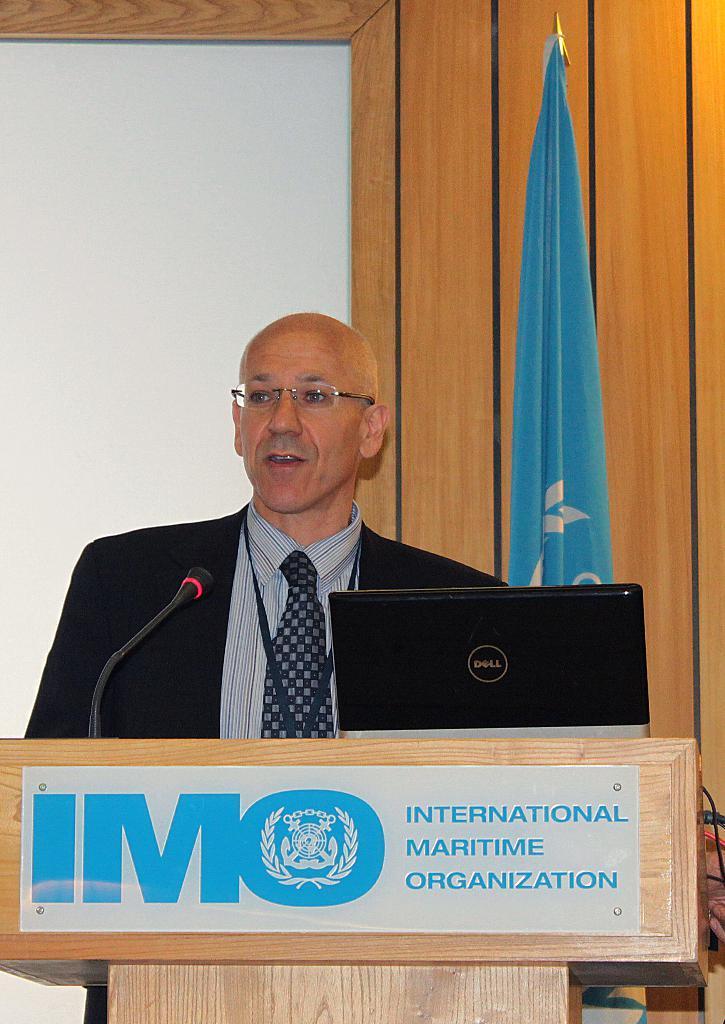Could you give a brief overview of what you see in this image? In this image I can see the person wearing the blazer, shirt and the tie and the person is standing in-front of the podium. On the podium I can see the mic and the laptop. I can also see the board attached to the podium. In the background I can see the flag and there is a white and brown color background. 